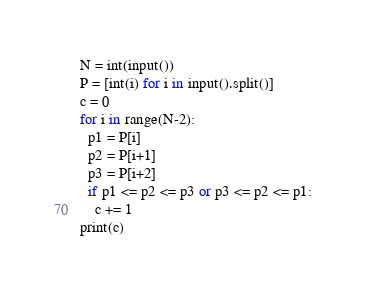<code> <loc_0><loc_0><loc_500><loc_500><_Python_>N = int(input())
P = [int(i) for i in input().split()]
c = 0
for i in range(N-2):
  p1 = P[i]
  p2 = P[i+1]
  p3 = P[i+2]
  if p1 <= p2 <= p3 or p3 <= p2 <= p1:
    c += 1
print(c)</code> 